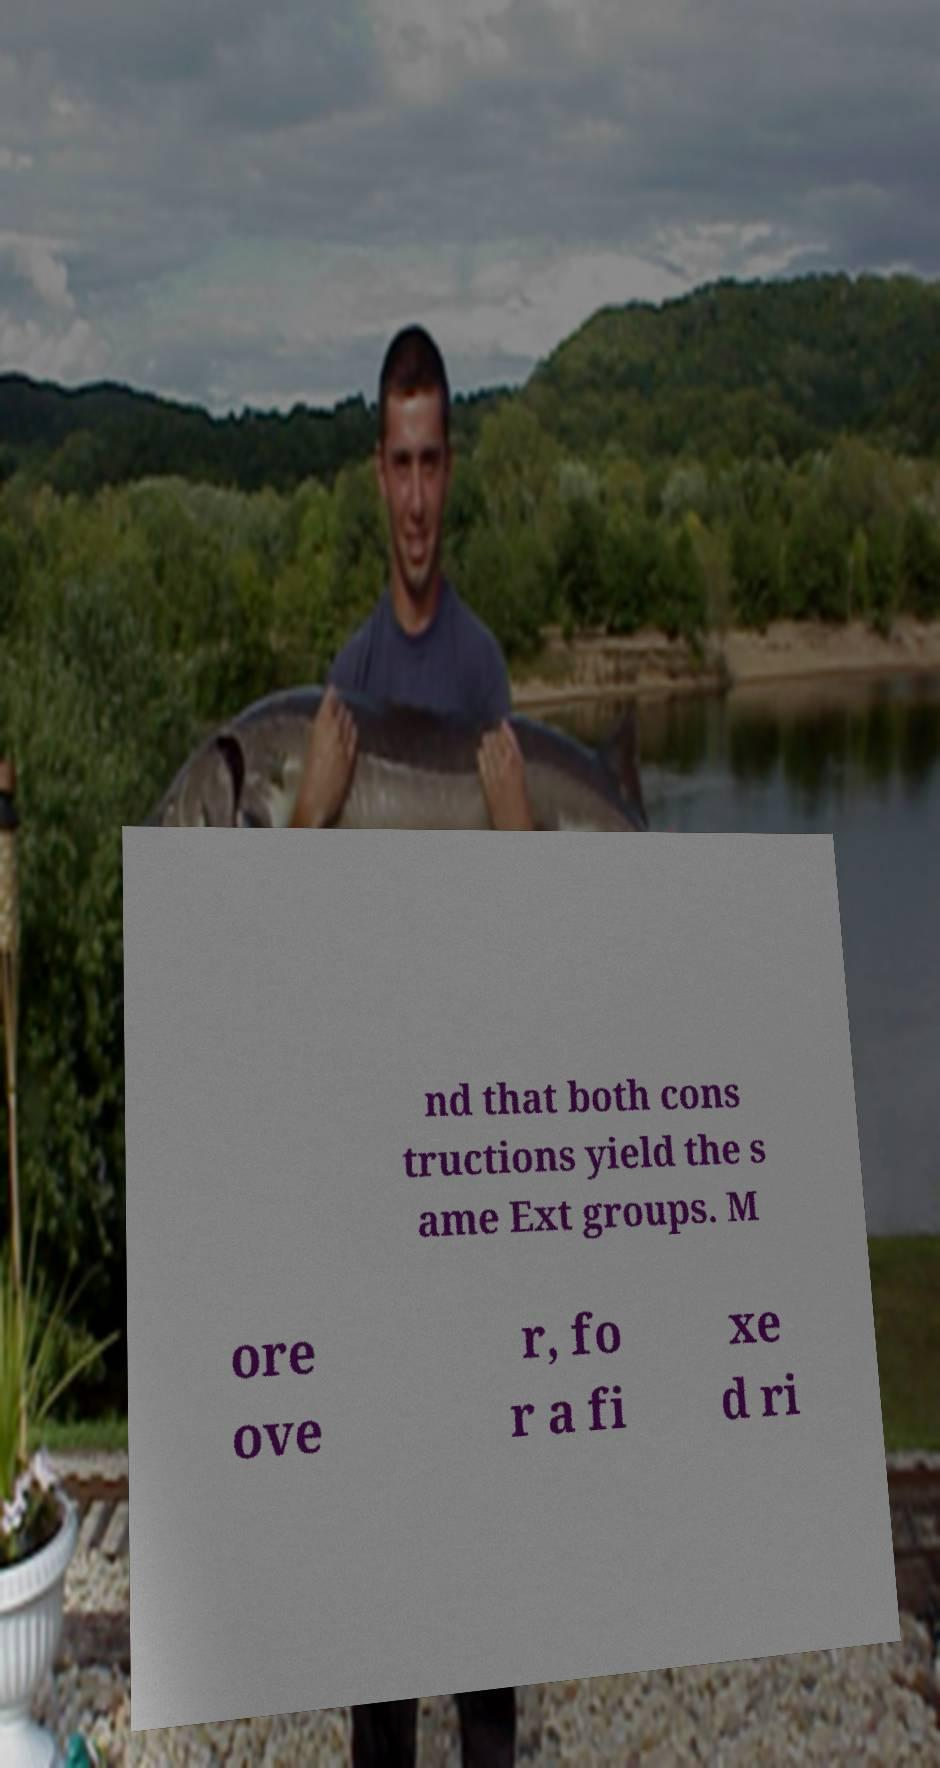What messages or text are displayed in this image? I need them in a readable, typed format. nd that both cons tructions yield the s ame Ext groups. M ore ove r, fo r a fi xe d ri 